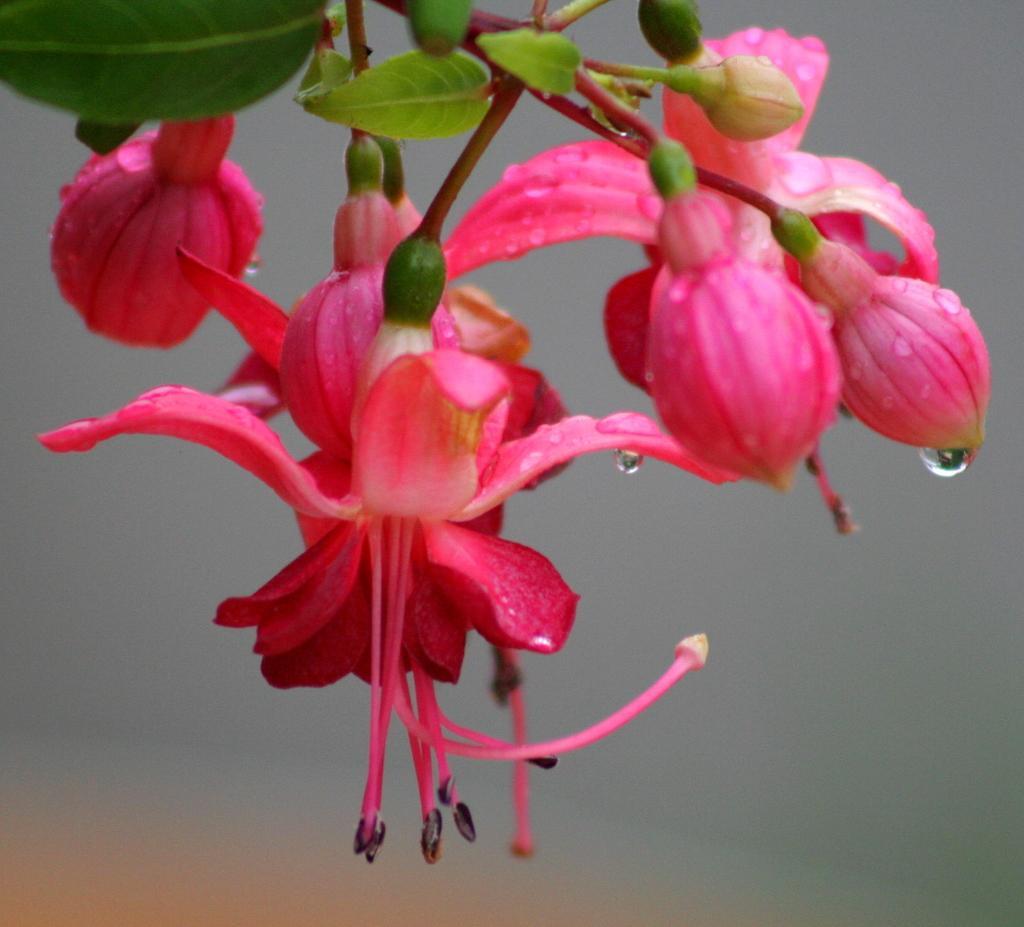Describe this image in one or two sentences. In this image I can see few flowers in pink color and I can also see few leaves in green color and I can see the blurred background. 